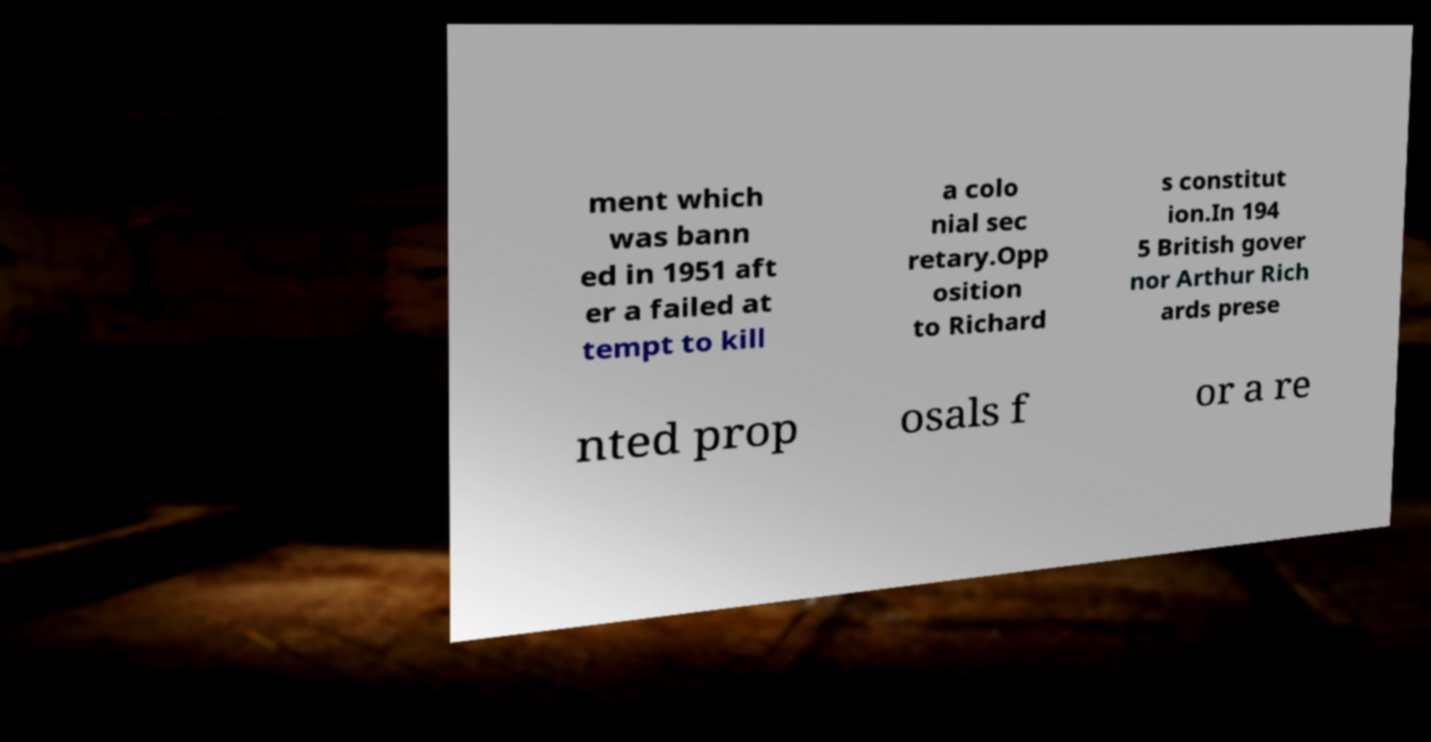I need the written content from this picture converted into text. Can you do that? ment which was bann ed in 1951 aft er a failed at tempt to kill a colo nial sec retary.Opp osition to Richard s constitut ion.In 194 5 British gover nor Arthur Rich ards prese nted prop osals f or a re 